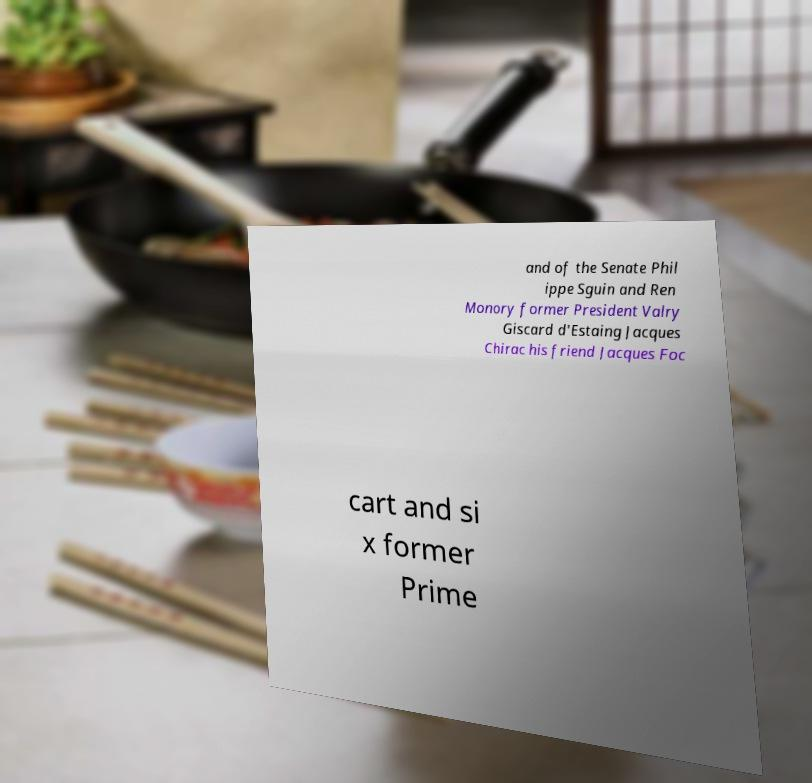Could you extract and type out the text from this image? and of the Senate Phil ippe Sguin and Ren Monory former President Valry Giscard d'Estaing Jacques Chirac his friend Jacques Foc cart and si x former Prime 